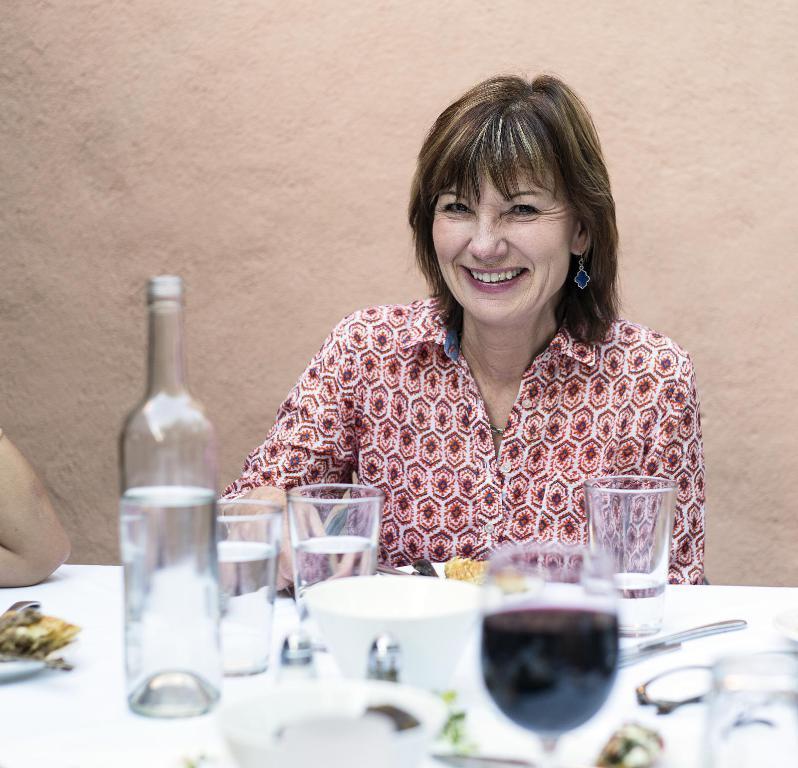Describe this image in one or two sentences. This image consists of a table on which there are bottle, glasses, Bowl, Cup, spoon, fork. There is a woman sitting near the table. She is smiling. 